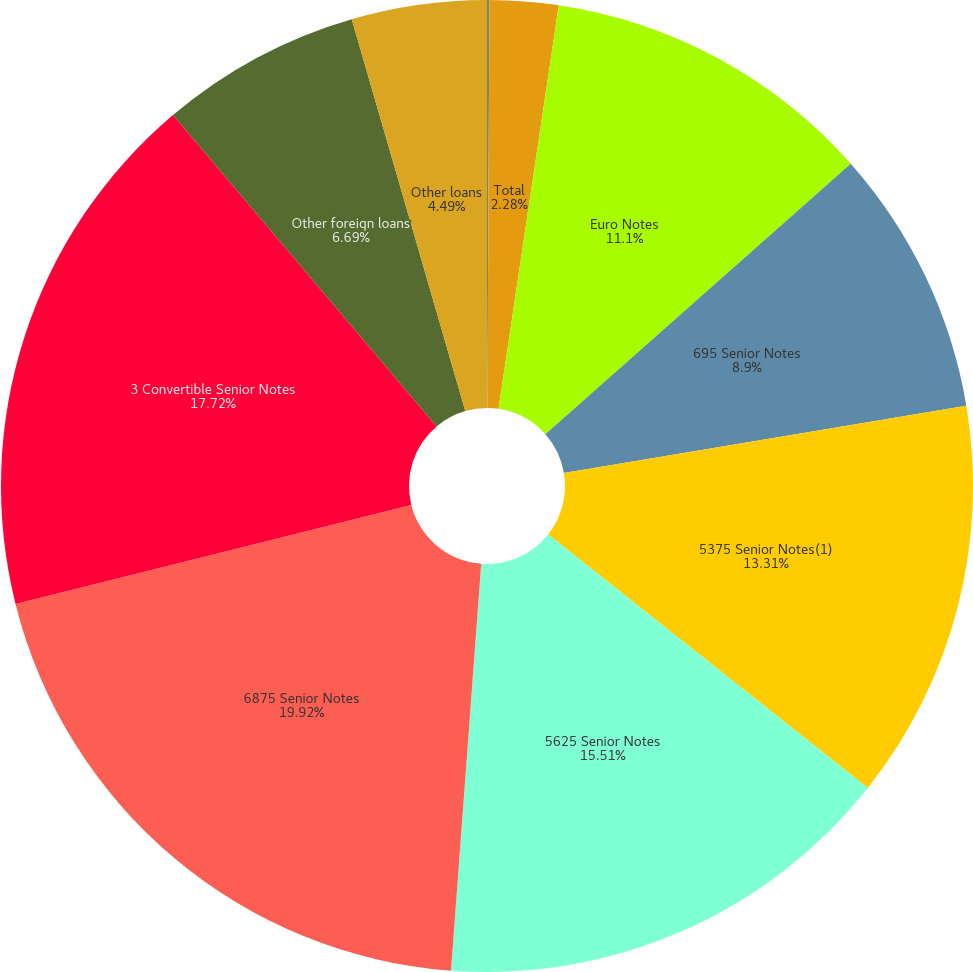<chart> <loc_0><loc_0><loc_500><loc_500><pie_chart><fcel>Interest rate swaps<fcel>Total<fcel>Euro Notes<fcel>695 Senior Notes<fcel>5375 Senior Notes(1)<fcel>5625 Senior Notes<fcel>6875 Senior Notes<fcel>3 Convertible Senior Notes<fcel>Other foreign loans<fcel>Other loans<nl><fcel>0.08%<fcel>2.28%<fcel>11.1%<fcel>8.9%<fcel>13.31%<fcel>15.51%<fcel>19.92%<fcel>17.72%<fcel>6.69%<fcel>4.49%<nl></chart> 